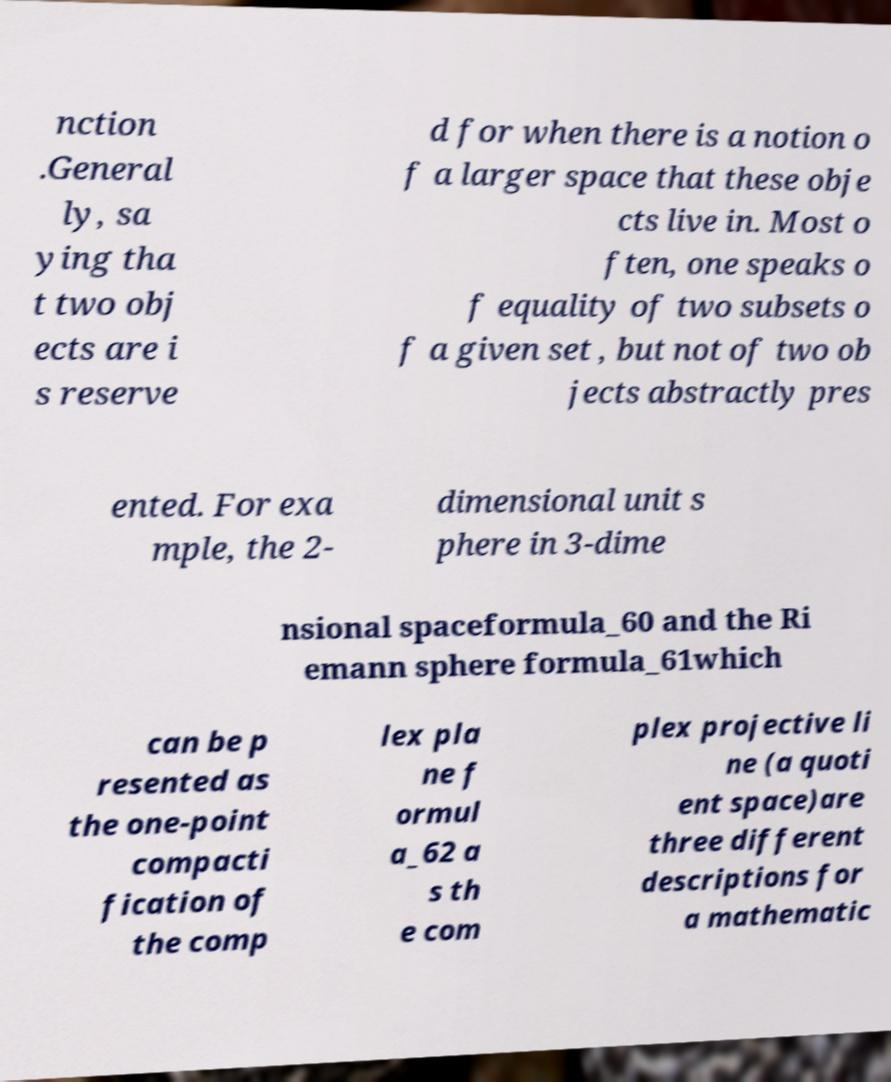Could you assist in decoding the text presented in this image and type it out clearly? nction .General ly, sa ying tha t two obj ects are i s reserve d for when there is a notion o f a larger space that these obje cts live in. Most o ften, one speaks o f equality of two subsets o f a given set , but not of two ob jects abstractly pres ented. For exa mple, the 2- dimensional unit s phere in 3-dime nsional spaceformula_60 and the Ri emann sphere formula_61which can be p resented as the one-point compacti fication of the comp lex pla ne f ormul a_62 a s th e com plex projective li ne (a quoti ent space)are three different descriptions for a mathematic 